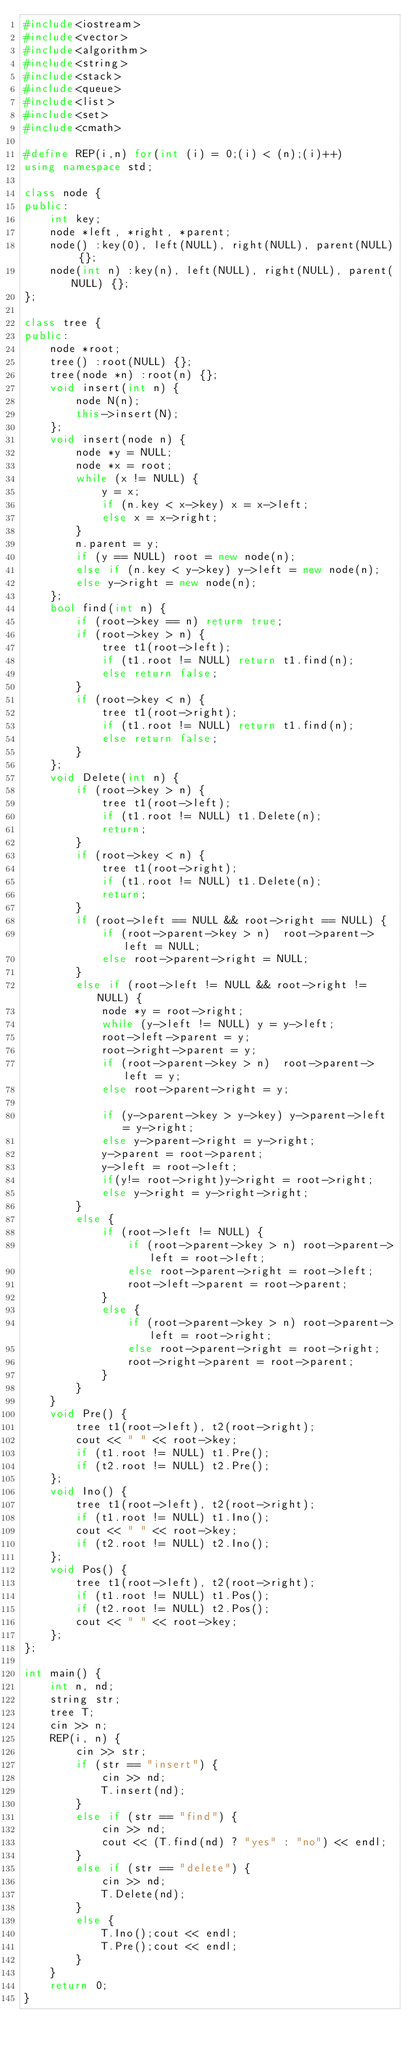<code> <loc_0><loc_0><loc_500><loc_500><_C++_>#include<iostream>
#include<vector>
#include<algorithm>
#include<string>
#include<stack>
#include<queue>
#include<list>
#include<set>
#include<cmath>

#define REP(i,n) for(int (i) = 0;(i) < (n);(i)++)
using namespace std;

class node {
public:
	int key;
	node *left, *right, *parent;
	node() :key(0), left(NULL), right(NULL), parent(NULL) {};
	node(int n) :key(n), left(NULL), right(NULL), parent(NULL) {};
};

class tree {
public:
	node *root;
	tree() :root(NULL) {};
	tree(node *n) :root(n) {};
	void insert(int n) {
		node N(n);
		this->insert(N);
	};
	void insert(node n) {
		node *y = NULL;
		node *x = root;
		while (x != NULL) {
			y = x;
			if (n.key < x->key) x = x->left;
			else x = x->right;
		}
		n.parent = y;
		if (y == NULL) root = new node(n);
		else if (n.key < y->key) y->left = new node(n);
		else y->right = new node(n);
	};
	bool find(int n) {
		if (root->key == n) return true;
		if (root->key > n) {
			tree t1(root->left);
			if (t1.root != NULL) return t1.find(n);
			else return false;
		}
		if (root->key < n) {
			tree t1(root->right);
			if (t1.root != NULL) return t1.find(n);
			else return false;
		}
	};
	void Delete(int n) {
		if (root->key > n) {
			tree t1(root->left);
			if (t1.root != NULL) t1.Delete(n);
			return;
		}
		if (root->key < n) {
			tree t1(root->right);
			if (t1.root != NULL) t1.Delete(n);
			return;
		}
		if (root->left == NULL && root->right == NULL) {
			if (root->parent->key > n)  root->parent->left = NULL;
			else root->parent->right = NULL;
		}
		else if (root->left != NULL && root->right != NULL) {
			node *y = root->right;
			while (y->left != NULL) y = y->left;
			root->left->parent = y;
			root->right->parent = y;
			if (root->parent->key > n)  root->parent->left = y;
			else root->parent->right = y;

			if (y->parent->key > y->key) y->parent->left = y->right;
			else y->parent->right = y->right;
			y->parent = root->parent;
			y->left = root->left;
			if(y!= root->right)y->right = root->right;
			else y->right = y->right->right;
		}
		else {
			if (root->left != NULL) {
				if (root->parent->key > n) root->parent->left = root->left;
				else root->parent->right = root->left;
				root->left->parent = root->parent;
			}
			else {
				if (root->parent->key > n) root->parent->left = root->right;
				else root->parent->right = root->right;
				root->right->parent = root->parent;
			}
		}
	}
	void Pre() {
		tree t1(root->left), t2(root->right);
		cout << " " << root->key;
		if (t1.root != NULL) t1.Pre();
		if (t2.root != NULL) t2.Pre();
	};
	void Ino() {
		tree t1(root->left), t2(root->right);
		if (t1.root != NULL) t1.Ino();
		cout << " " << root->key;
		if (t2.root != NULL) t2.Ino();
	};
	void Pos() {
		tree t1(root->left), t2(root->right);
		if (t1.root != NULL) t1.Pos();
		if (t2.root != NULL) t2.Pos();
		cout << " " << root->key;
	};
};

int main() {
	int n, nd;
	string str;
	tree T;
	cin >> n;
	REP(i, n) {
		cin >> str;
		if (str == "insert") {
			cin >> nd;
			T.insert(nd);
		}
		else if (str == "find") {
			cin >> nd;
			cout << (T.find(nd) ? "yes" : "no") << endl;
		}
		else if (str == "delete") {
			cin >> nd;
			T.Delete(nd);
		}
		else {
			T.Ino();cout << endl;
			T.Pre();cout << endl;
		}
	}
	return 0;
}</code> 